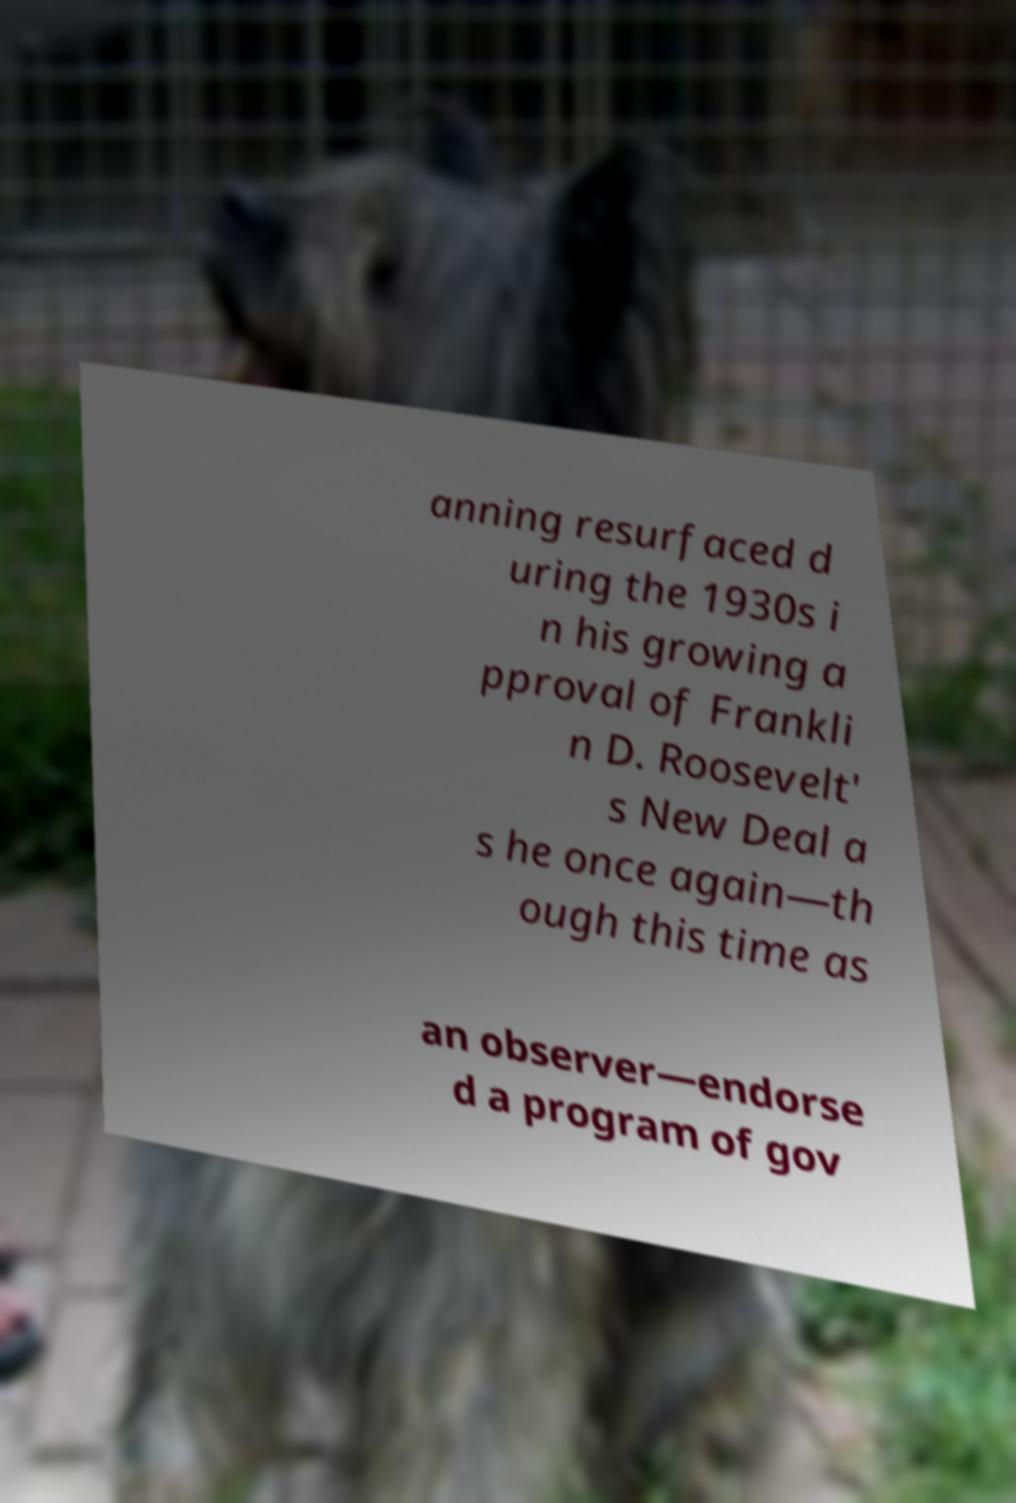Please read and relay the text visible in this image. What does it say? anning resurfaced d uring the 1930s i n his growing a pproval of Frankli n D. Roosevelt' s New Deal a s he once again—th ough this time as an observer—endorse d a program of gov 